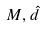Convert formula to latex. <formula><loc_0><loc_0><loc_500><loc_500>M , \hat { d }</formula> 